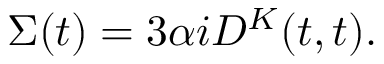<formula> <loc_0><loc_0><loc_500><loc_500>\Sigma ( t ) = { 3 } \alpha i D ^ { K } ( t , t ) .</formula> 